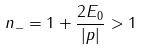Convert formula to latex. <formula><loc_0><loc_0><loc_500><loc_500>n _ { - } = 1 + \frac { 2 E _ { 0 } } { \left | p \right | } > 1</formula> 